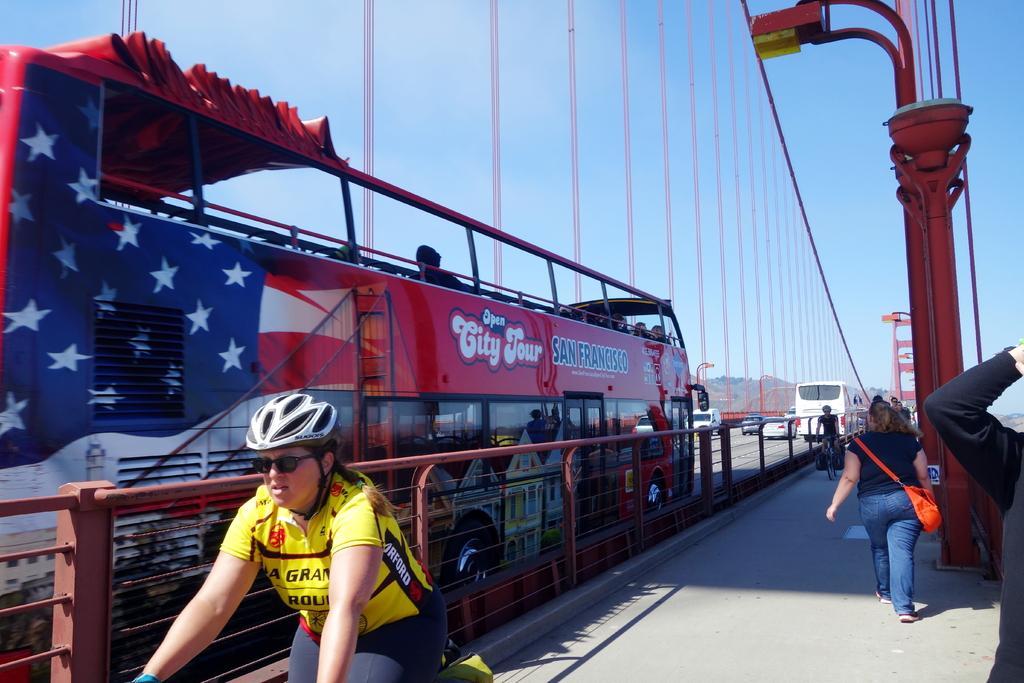How would you summarize this image in a sentence or two? Here In this picture we can see people riding bicycleS here and there and there are people walking through the sidewalk and there is a light post present at the right side and in the left side we can see a bus on the road and there are other vehicles on the road 